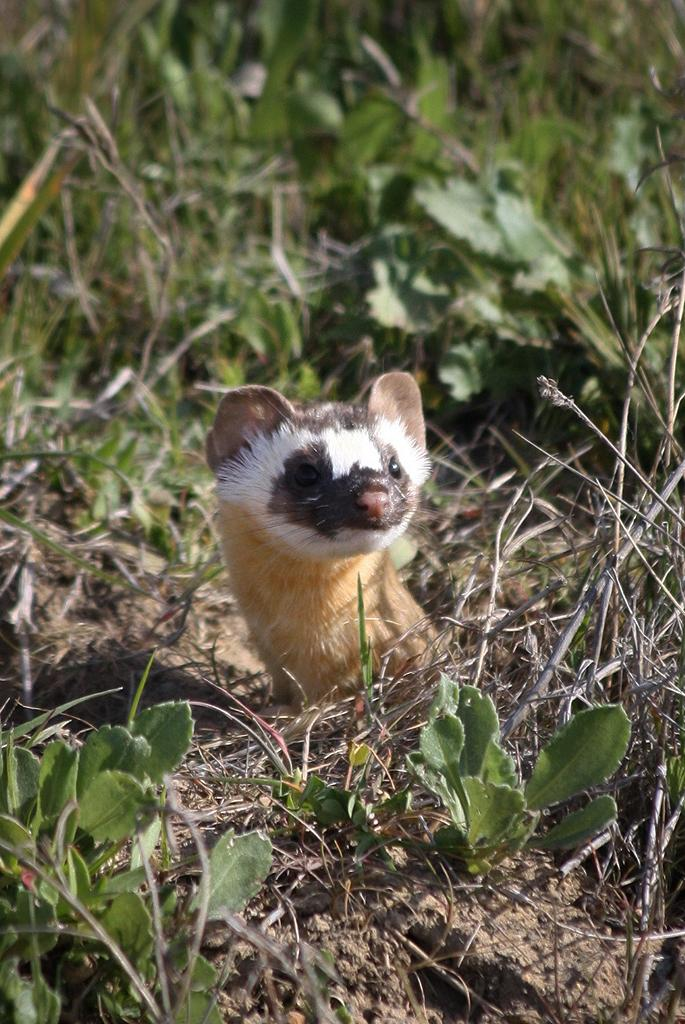What type of animal is present in the image? There is an animal in the image, but the specific type of animal is not mentioned in the facts. Can you describe the position of the animal in the image? The animal is on the ground in the image. What type of vegetation can be seen in the image? There is grass in the image. Based on the lighting and visibility, can you infer the time of day when the image was taken? The image was likely taken during the day, as the lighting suggests it is not nighttime. How many friends is the animal seen rolling with in the image? There is no indication in the image that the animal is rolling or interacting with any friends. Is the animal wearing a chain around its neck in the image? There is no chain visible around the animal's neck in the image. 